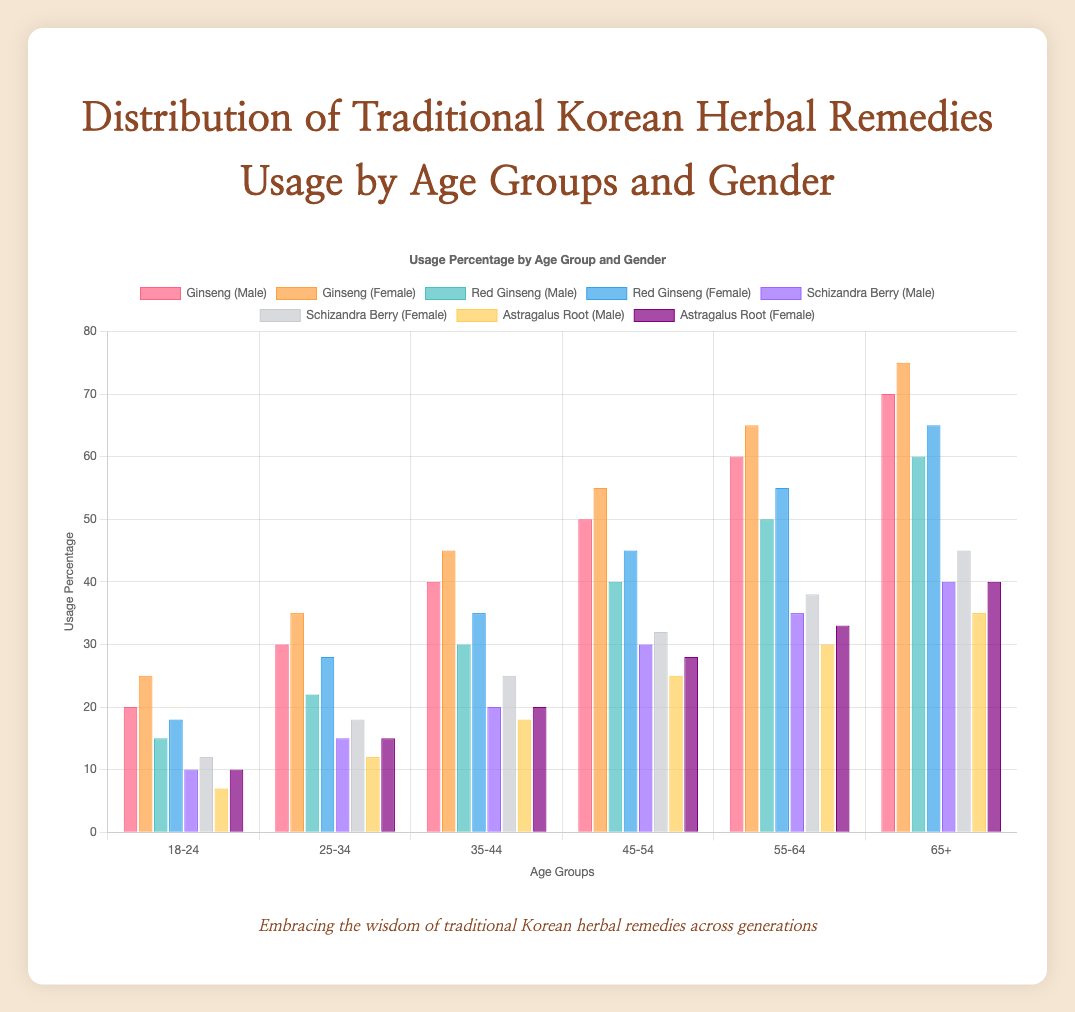Who has the highest usage percentage of Ginseng in the 35-44 age group? To find this, look at the Ginseng usage bars for the 35-44 age group and compare the heights between males and females. The female bar is higher.
Answer: Female How does the usage of Red Ginseng change from the 18-24 age group to the 65+ age group for males? Identify the Red Ginseng bars for males across the age groups and note the trend. The values increase from 15 to 60.
Answer: Increases What is the average usage percentage of Schizandra Berry for females across all age groups? Calculate the average by summing up the values for females across all age groups (12 + 18 + 25 + 32 + 38 + 45 = 170) and divide by the number of age groups (170/6).
Answer: 28.33 Compare the usage of Astragalus Root between males and females in the 55-64 age group. Compare the heights of the Astragalus Root bars for males (30) and females (33) in the 55-64 age group. Females use slightly more.
Answer: Females use more Which gender has a higher total usage percentage of traditional herbal remedies in the 45-54 age group? Add up the usage percentages for both genders in the 45-54 group. Male totals: 50 + 40 + 30 + 25 = 145. Female totals: 55 + 45 + 32 + 28 = 160.
Answer: Female How does the usage of all herbal remedies combined compare between the 18-24 and 65+ age groups for females? Add the usage percentages for all remedies in both age groups for females. 18-24: 25 + 18 + 12 + 10 = 65. 65+: 75 + 65 + 45 + 40 = 225.
Answer: Increases What is the difference in Red Ginseng usage between males and females in the 25-34 age group? Subtract the male value (22) from the female value (28) for Red Ginseng in the 25-34 age group.
Answer: 6 Which age group shows the highest combined usage percentage for Ginseng and Red Ginseng in males? Sum the Ginseng and Red Ginseng usage percentages for all age groups in males and compare: 18-24: 35, 25-34: 52, 35-44: 70, 45-54: 90, 55-64: 110, 65+: 130.
Answer: 65+ What is the overall trend in Astragalus Root usage by age group for both genders? Look at the Astragalus Root bars for both genders across all age groups. Generally, the values increase for both genders as the age increases.
Answer: Increases 